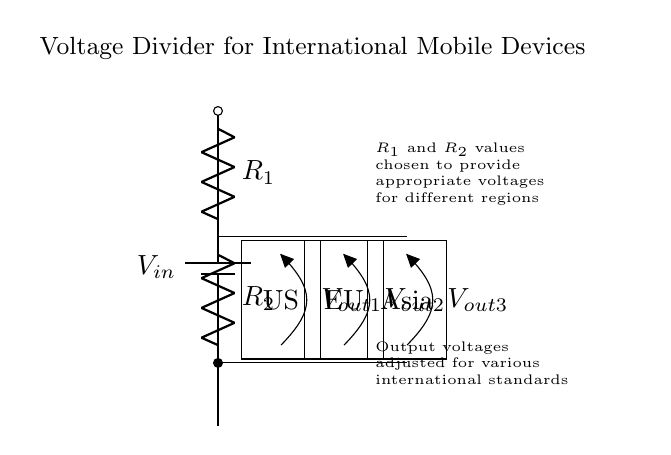What is the type of power supply used in the circuit? The circuit uses a battery symbol, indicating a direct current (DC) power supply.
Answer: Battery What are the components in the voltage divider? The circuit contains two resistors, labeled R1 and R2. These resistors form the basic voltage divider network by dividing the input voltage.
Answer: R1, R2 What are the regions represented in the output connections? The output connections (Vout1, Vout2, Vout3) are labeled US, EU, and Asia, indicating the voltage outputs are designed for mobile devices from the United States, the European Union, and Asia respectively.
Answer: US, EU, Asia What is the function of the resistors in this circuit? The resistors R1 and R2 divide the input voltage into smaller output voltages suitable for devices from different regions.
Answer: Divide voltage How many output voltages are indicated in the diagram? The circuit shows three output voltages (Vout1, Vout2, Vout3) for different regional devices, effectively catering to three international standards.
Answer: Three What does the annotation about R1 and R2 state? It specifies that the values of R1 and R2 were chosen to provide appropriate voltages for different regions, showing that their values are critical in determining the output voltage.
Answer: Appropriate voltages Why is it necessary to adjust output voltages for international standards? Devices from different countries often require different voltage levels; hence adjusting the output voltages helps ensure compatibility with various devices and reduces the risk of damage.
Answer: Compatibility 